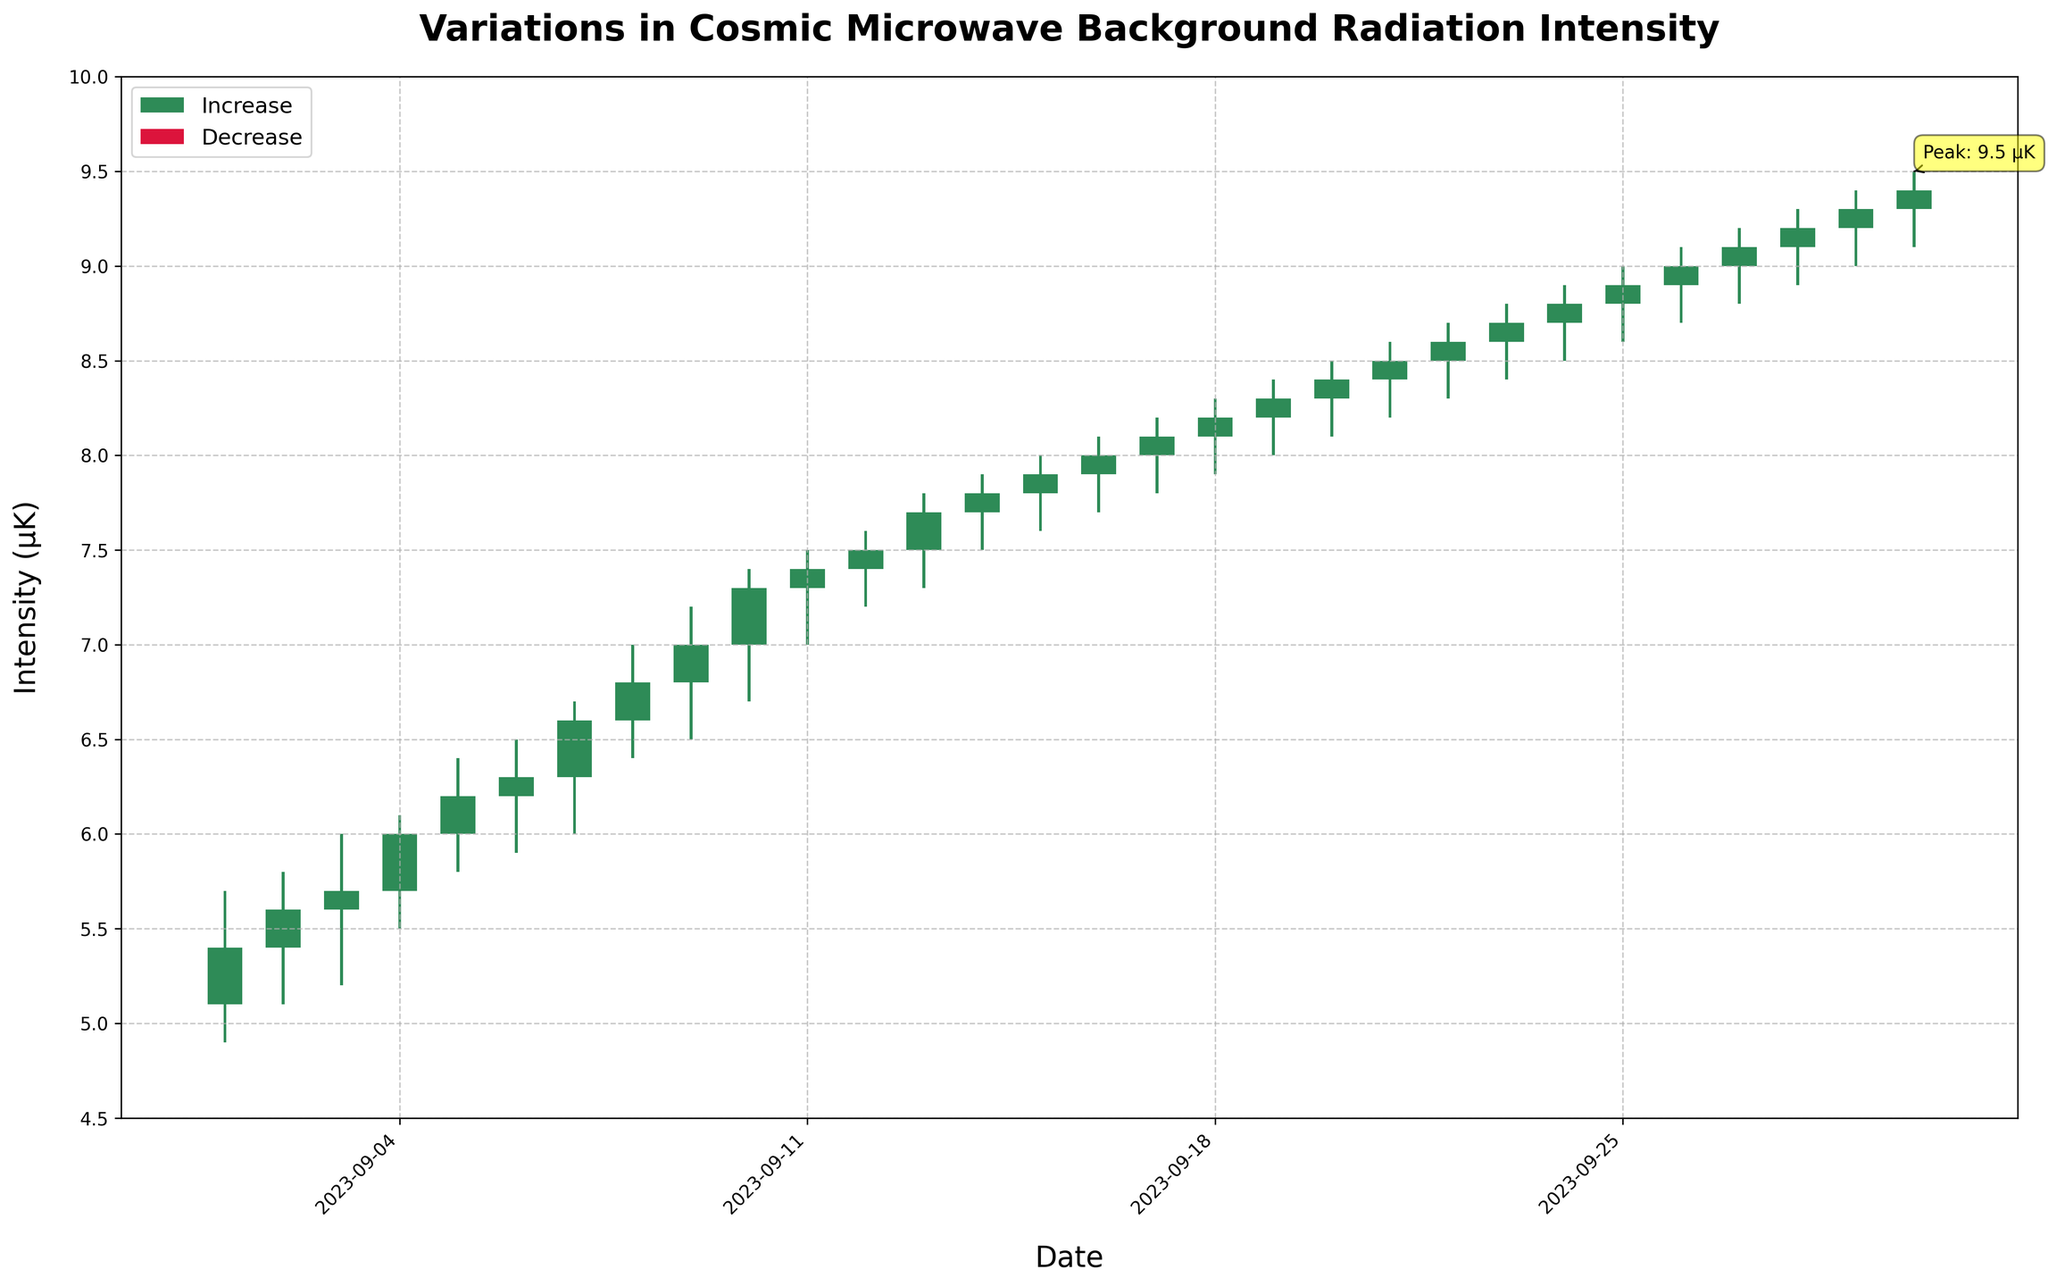What is the title of the plot? The title is located at the top center of the figure, indicating the overall theme or subject of the plot. It reads: "Variations in Cosmic Microwave Background Radiation Intensity".
Answer: Variations in Cosmic Microwave Background Radiation Intensity What are the colors used to represent increases and decreases in intensity? The colors for increases and decreases can be observed in the candlestick bars and the legend box. A seagreen color is used for increases, and a crimson color is used for decreases.
Answer: Seagreen for increases, Crimson for decreases How many data points (days) are represented in the plot? Each stick in the plot represents a data point, and they are plotted for each day of the month. Since the plot represents data for each day in September, there are 30 data points.
Answer: 30 What is the highest intensity value recorded in the plot, and on which date does it occur? The highest intensity value can be found by locating the highest point on the plot. According to the annotation and the heights of the candlestick, the highest intensity value is 9.5 μK, which occurs on September 30.
Answer: 9.5 μK on September 30 Which day shows the largest single-day increase in intensity and what is the value of this increase? To find the day with the largest single-day increase, compare the difference between the opening and closing intensity values for each day. The day with the largest difference is September 10, showing a rise from 7.0 μK to 7.3 μK, making the increase 0.3 μK.
Answer: September 10, 0.3 μK On which days did the intensity decrease? Days with a decrease in intensity are represented by crimson-colored candlesticks. Observing the plot, intensity decreases can be seen on September 1st, 2nd, and 4th.
Answer: September 1, 2, and 4 What is the average closing intensity for the month of September? Sum all the closing intensity values over the month (5.4 + 5.6 + 5.7 + 6.0 + 6.2 + 6.3 + 6.6 + 6.8 + 7.0 + 7.3 + 7.4 + 7.5 + 7.7 + 7.8 + 8.0 + 8.1 + 8.2 + 8.3 + 8.4 + 8.5 + 8.6 + 8.7 + 8.8 + 8.9 + 9.0 + 9.1 + 9.2 + 9.3 + 9.4), then divide the sum by 30. The calculation yields 7.255 μK as the average closing intensity.
Answer: 7.255 μK On which days did both the highest and lowest intensities exceed 8 μK? To answer, we must find days where both the highest and lowest intensities were above 8 μK. From the data, this occurs on September 20, 21, 22, 23, 24, 25, 26, 27, 28, 29, and 30.
Answer: September 20-30 What's the difference between the highest and lowest recorded intensity for the entire month? First, identify the highest intensity of 9.5 μK (September 30) and the lowest intensity of 4.9 μK (September 1). Subtract the lowest from the highest: 9.5 μK - 4.9 μK = 4.6 μK.
Answer: 4.6 μK On which date did the closing intensity exceed 9 μK for the first time? By checking the closing intensity values above 9 μK and referring to the dates, the first occurrence is on September 29, where the closing intensity is 9.3 μK.
Answer: September 29 